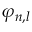<formula> <loc_0><loc_0><loc_500><loc_500>\varphi _ { n , l }</formula> 